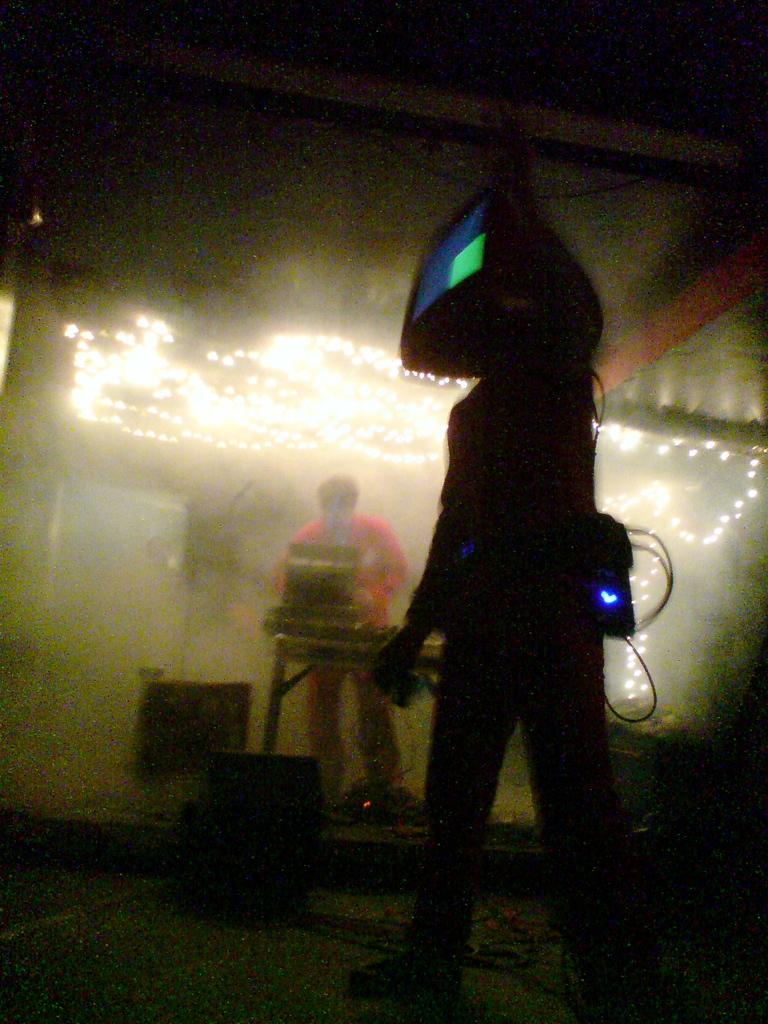What is the overall lighting condition in the image? The image is dark. Can you describe the person in the image? There is a person standing in the image. What electronic device is visible in the image? There is a television in the image. What can be seen in the background of the image? There are objects on a surface in the background of the image, and lights are also present. What is the birth rate of the person in the image? There is no information about the person's birth rate in the image. Can you see a gun in the image? There is no gun present in the image. 